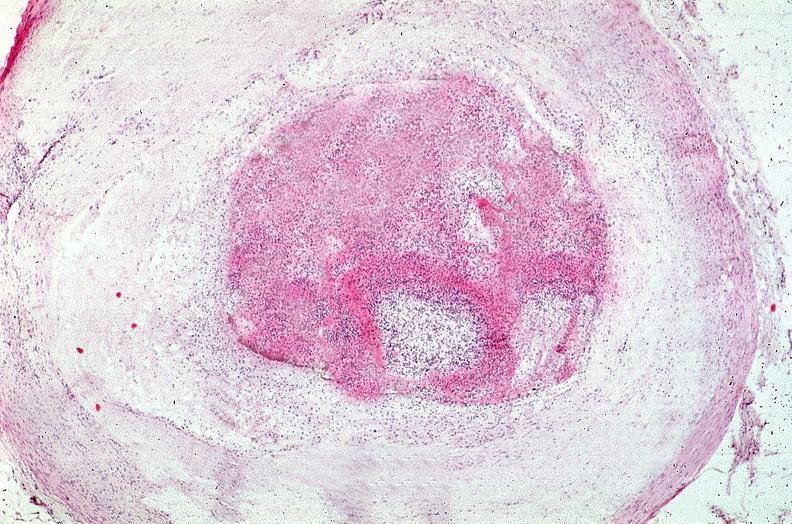does this photo of infant from head to toe show coronary artery with atherosclerosis and thrombotic occlusion?
Answer the question using a single word or phrase. No 